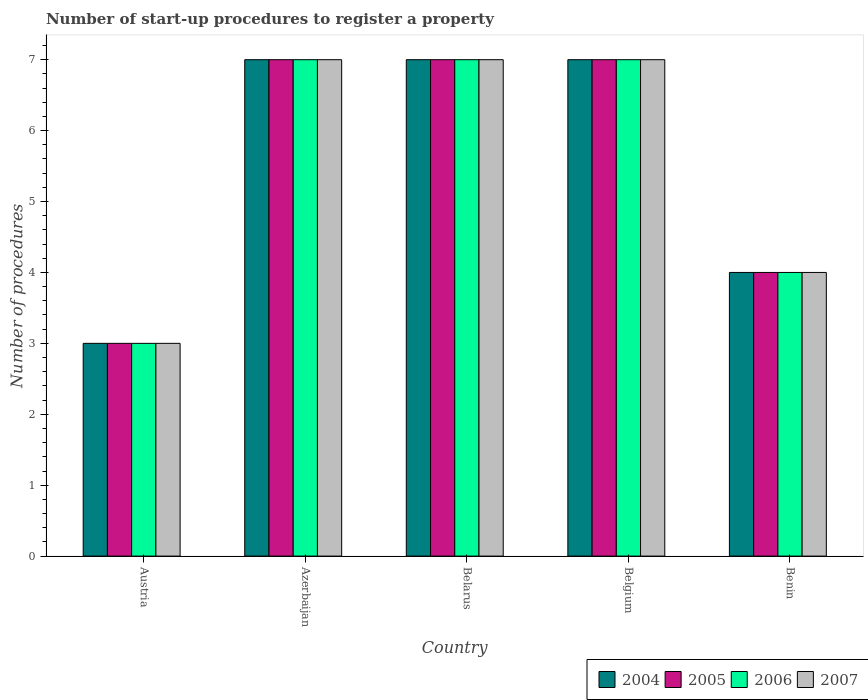How many different coloured bars are there?
Offer a very short reply. 4. How many groups of bars are there?
Offer a very short reply. 5. Are the number of bars per tick equal to the number of legend labels?
Offer a very short reply. Yes. Are the number of bars on each tick of the X-axis equal?
Ensure brevity in your answer.  Yes. How many bars are there on the 1st tick from the left?
Your answer should be compact. 4. How many bars are there on the 2nd tick from the right?
Make the answer very short. 4. What is the label of the 5th group of bars from the left?
Give a very brief answer. Benin. In how many cases, is the number of bars for a given country not equal to the number of legend labels?
Provide a succinct answer. 0. What is the number of procedures required to register a property in 2006 in Benin?
Your answer should be very brief. 4. In which country was the number of procedures required to register a property in 2006 maximum?
Your answer should be very brief. Azerbaijan. What is the difference between the number of procedures required to register a property in 2004 in Austria and the number of procedures required to register a property in 2005 in Belarus?
Give a very brief answer. -4. What is the difference between the number of procedures required to register a property of/in 2006 and number of procedures required to register a property of/in 2007 in Benin?
Offer a very short reply. 0. What is the difference between the highest and the lowest number of procedures required to register a property in 2006?
Keep it short and to the point. 4. Is it the case that in every country, the sum of the number of procedures required to register a property in 2005 and number of procedures required to register a property in 2004 is greater than the sum of number of procedures required to register a property in 2007 and number of procedures required to register a property in 2006?
Your answer should be very brief. No. Is it the case that in every country, the sum of the number of procedures required to register a property in 2005 and number of procedures required to register a property in 2004 is greater than the number of procedures required to register a property in 2007?
Give a very brief answer. Yes. How many countries are there in the graph?
Your response must be concise. 5. Are the values on the major ticks of Y-axis written in scientific E-notation?
Make the answer very short. No. Does the graph contain any zero values?
Offer a terse response. No. Does the graph contain grids?
Offer a very short reply. No. Where does the legend appear in the graph?
Provide a short and direct response. Bottom right. What is the title of the graph?
Make the answer very short. Number of start-up procedures to register a property. Does "1978" appear as one of the legend labels in the graph?
Your answer should be very brief. No. What is the label or title of the X-axis?
Your response must be concise. Country. What is the label or title of the Y-axis?
Your answer should be very brief. Number of procedures. What is the Number of procedures in 2006 in Austria?
Offer a very short reply. 3. What is the Number of procedures in 2007 in Austria?
Your answer should be compact. 3. What is the Number of procedures of 2006 in Azerbaijan?
Your answer should be very brief. 7. What is the Number of procedures of 2007 in Azerbaijan?
Ensure brevity in your answer.  7. What is the Number of procedures in 2004 in Belgium?
Provide a short and direct response. 7. What is the Number of procedures in 2007 in Belgium?
Your answer should be compact. 7. What is the Number of procedures in 2004 in Benin?
Offer a terse response. 4. What is the Number of procedures of 2005 in Benin?
Offer a terse response. 4. What is the Number of procedures of 2006 in Benin?
Offer a terse response. 4. Across all countries, what is the maximum Number of procedures in 2004?
Your answer should be very brief. 7. Across all countries, what is the maximum Number of procedures of 2005?
Ensure brevity in your answer.  7. Across all countries, what is the maximum Number of procedures of 2006?
Keep it short and to the point. 7. Across all countries, what is the minimum Number of procedures of 2006?
Your answer should be very brief. 3. What is the total Number of procedures of 2006 in the graph?
Offer a terse response. 28. What is the difference between the Number of procedures of 2005 in Austria and that in Azerbaijan?
Offer a very short reply. -4. What is the difference between the Number of procedures of 2004 in Austria and that in Belarus?
Offer a terse response. -4. What is the difference between the Number of procedures in 2005 in Austria and that in Belarus?
Provide a short and direct response. -4. What is the difference between the Number of procedures in 2006 in Austria and that in Belarus?
Your answer should be very brief. -4. What is the difference between the Number of procedures in 2007 in Austria and that in Belarus?
Keep it short and to the point. -4. What is the difference between the Number of procedures in 2006 in Austria and that in Belgium?
Your answer should be compact. -4. What is the difference between the Number of procedures in 2007 in Austria and that in Belgium?
Make the answer very short. -4. What is the difference between the Number of procedures in 2004 in Austria and that in Benin?
Offer a terse response. -1. What is the difference between the Number of procedures of 2005 in Austria and that in Benin?
Make the answer very short. -1. What is the difference between the Number of procedures of 2006 in Austria and that in Benin?
Your answer should be very brief. -1. What is the difference between the Number of procedures in 2004 in Azerbaijan and that in Belarus?
Make the answer very short. 0. What is the difference between the Number of procedures in 2005 in Azerbaijan and that in Belarus?
Provide a short and direct response. 0. What is the difference between the Number of procedures of 2005 in Azerbaijan and that in Belgium?
Offer a terse response. 0. What is the difference between the Number of procedures of 2006 in Azerbaijan and that in Belgium?
Ensure brevity in your answer.  0. What is the difference between the Number of procedures of 2004 in Azerbaijan and that in Benin?
Keep it short and to the point. 3. What is the difference between the Number of procedures of 2005 in Azerbaijan and that in Benin?
Your answer should be compact. 3. What is the difference between the Number of procedures in 2007 in Azerbaijan and that in Benin?
Keep it short and to the point. 3. What is the difference between the Number of procedures in 2005 in Belarus and that in Belgium?
Offer a very short reply. 0. What is the difference between the Number of procedures of 2006 in Belarus and that in Belgium?
Your response must be concise. 0. What is the difference between the Number of procedures in 2007 in Belarus and that in Belgium?
Ensure brevity in your answer.  0. What is the difference between the Number of procedures in 2005 in Belarus and that in Benin?
Keep it short and to the point. 3. What is the difference between the Number of procedures of 2006 in Belarus and that in Benin?
Provide a short and direct response. 3. What is the difference between the Number of procedures in 2004 in Belgium and that in Benin?
Provide a short and direct response. 3. What is the difference between the Number of procedures in 2007 in Belgium and that in Benin?
Your response must be concise. 3. What is the difference between the Number of procedures in 2004 in Austria and the Number of procedures in 2005 in Azerbaijan?
Offer a very short reply. -4. What is the difference between the Number of procedures of 2004 in Austria and the Number of procedures of 2006 in Azerbaijan?
Make the answer very short. -4. What is the difference between the Number of procedures of 2005 in Austria and the Number of procedures of 2007 in Azerbaijan?
Provide a short and direct response. -4. What is the difference between the Number of procedures of 2006 in Austria and the Number of procedures of 2007 in Azerbaijan?
Offer a terse response. -4. What is the difference between the Number of procedures in 2004 in Austria and the Number of procedures in 2005 in Belarus?
Your answer should be very brief. -4. What is the difference between the Number of procedures of 2004 in Austria and the Number of procedures of 2006 in Belarus?
Your response must be concise. -4. What is the difference between the Number of procedures of 2004 in Austria and the Number of procedures of 2007 in Belarus?
Give a very brief answer. -4. What is the difference between the Number of procedures of 2005 in Austria and the Number of procedures of 2006 in Belarus?
Make the answer very short. -4. What is the difference between the Number of procedures of 2005 in Austria and the Number of procedures of 2007 in Belarus?
Your response must be concise. -4. What is the difference between the Number of procedures of 2006 in Austria and the Number of procedures of 2007 in Belarus?
Offer a terse response. -4. What is the difference between the Number of procedures in 2004 in Austria and the Number of procedures in 2005 in Belgium?
Keep it short and to the point. -4. What is the difference between the Number of procedures of 2004 in Austria and the Number of procedures of 2007 in Belgium?
Provide a succinct answer. -4. What is the difference between the Number of procedures of 2006 in Austria and the Number of procedures of 2007 in Belgium?
Make the answer very short. -4. What is the difference between the Number of procedures in 2004 in Austria and the Number of procedures in 2005 in Benin?
Keep it short and to the point. -1. What is the difference between the Number of procedures in 2004 in Austria and the Number of procedures in 2006 in Benin?
Make the answer very short. -1. What is the difference between the Number of procedures of 2005 in Austria and the Number of procedures of 2006 in Benin?
Your response must be concise. -1. What is the difference between the Number of procedures of 2006 in Austria and the Number of procedures of 2007 in Benin?
Make the answer very short. -1. What is the difference between the Number of procedures in 2004 in Azerbaijan and the Number of procedures in 2005 in Belarus?
Your response must be concise. 0. What is the difference between the Number of procedures in 2004 in Azerbaijan and the Number of procedures in 2007 in Belarus?
Make the answer very short. 0. What is the difference between the Number of procedures of 2005 in Azerbaijan and the Number of procedures of 2007 in Belarus?
Keep it short and to the point. 0. What is the difference between the Number of procedures of 2006 in Azerbaijan and the Number of procedures of 2007 in Belarus?
Make the answer very short. 0. What is the difference between the Number of procedures in 2004 in Azerbaijan and the Number of procedures in 2005 in Belgium?
Offer a very short reply. 0. What is the difference between the Number of procedures of 2005 in Azerbaijan and the Number of procedures of 2006 in Belgium?
Your answer should be very brief. 0. What is the difference between the Number of procedures of 2004 in Azerbaijan and the Number of procedures of 2006 in Benin?
Offer a terse response. 3. What is the difference between the Number of procedures of 2004 in Azerbaijan and the Number of procedures of 2007 in Benin?
Provide a succinct answer. 3. What is the difference between the Number of procedures of 2005 in Azerbaijan and the Number of procedures of 2006 in Benin?
Give a very brief answer. 3. What is the difference between the Number of procedures of 2006 in Azerbaijan and the Number of procedures of 2007 in Benin?
Give a very brief answer. 3. What is the difference between the Number of procedures of 2004 in Belarus and the Number of procedures of 2005 in Belgium?
Your answer should be very brief. 0. What is the difference between the Number of procedures of 2005 in Belarus and the Number of procedures of 2006 in Belgium?
Ensure brevity in your answer.  0. What is the difference between the Number of procedures of 2006 in Belarus and the Number of procedures of 2007 in Belgium?
Offer a very short reply. 0. What is the difference between the Number of procedures in 2004 in Belarus and the Number of procedures in 2007 in Benin?
Your answer should be compact. 3. What is the difference between the Number of procedures of 2005 in Belarus and the Number of procedures of 2006 in Benin?
Your response must be concise. 3. What is the difference between the Number of procedures of 2006 in Belarus and the Number of procedures of 2007 in Benin?
Offer a very short reply. 3. What is the difference between the Number of procedures of 2004 in Belgium and the Number of procedures of 2005 in Benin?
Give a very brief answer. 3. What is the difference between the Number of procedures in 2005 in Belgium and the Number of procedures in 2006 in Benin?
Ensure brevity in your answer.  3. What is the difference between the Number of procedures in 2005 in Belgium and the Number of procedures in 2007 in Benin?
Your response must be concise. 3. What is the difference between the Number of procedures in 2006 in Belgium and the Number of procedures in 2007 in Benin?
Ensure brevity in your answer.  3. What is the average Number of procedures of 2004 per country?
Your answer should be very brief. 5.6. What is the difference between the Number of procedures in 2004 and Number of procedures in 2005 in Austria?
Keep it short and to the point. 0. What is the difference between the Number of procedures in 2004 and Number of procedures in 2006 in Austria?
Provide a short and direct response. 0. What is the difference between the Number of procedures of 2004 and Number of procedures of 2007 in Austria?
Offer a very short reply. 0. What is the difference between the Number of procedures in 2004 and Number of procedures in 2007 in Azerbaijan?
Provide a succinct answer. 0. What is the difference between the Number of procedures in 2005 and Number of procedures in 2007 in Azerbaijan?
Your response must be concise. 0. What is the difference between the Number of procedures of 2006 and Number of procedures of 2007 in Azerbaijan?
Ensure brevity in your answer.  0. What is the difference between the Number of procedures of 2005 and Number of procedures of 2006 in Belarus?
Offer a terse response. 0. What is the difference between the Number of procedures of 2006 and Number of procedures of 2007 in Belarus?
Provide a short and direct response. 0. What is the difference between the Number of procedures in 2004 and Number of procedures in 2006 in Belgium?
Offer a terse response. 0. What is the difference between the Number of procedures in 2004 and Number of procedures in 2007 in Belgium?
Offer a very short reply. 0. What is the difference between the Number of procedures in 2005 and Number of procedures in 2006 in Belgium?
Offer a terse response. 0. What is the difference between the Number of procedures of 2006 and Number of procedures of 2007 in Belgium?
Keep it short and to the point. 0. What is the difference between the Number of procedures of 2004 and Number of procedures of 2005 in Benin?
Keep it short and to the point. 0. What is the difference between the Number of procedures in 2004 and Number of procedures in 2006 in Benin?
Make the answer very short. 0. What is the ratio of the Number of procedures in 2004 in Austria to that in Azerbaijan?
Keep it short and to the point. 0.43. What is the ratio of the Number of procedures of 2005 in Austria to that in Azerbaijan?
Offer a terse response. 0.43. What is the ratio of the Number of procedures of 2006 in Austria to that in Azerbaijan?
Offer a terse response. 0.43. What is the ratio of the Number of procedures of 2007 in Austria to that in Azerbaijan?
Your answer should be compact. 0.43. What is the ratio of the Number of procedures in 2004 in Austria to that in Belarus?
Provide a short and direct response. 0.43. What is the ratio of the Number of procedures of 2005 in Austria to that in Belarus?
Your answer should be very brief. 0.43. What is the ratio of the Number of procedures of 2006 in Austria to that in Belarus?
Make the answer very short. 0.43. What is the ratio of the Number of procedures of 2007 in Austria to that in Belarus?
Offer a terse response. 0.43. What is the ratio of the Number of procedures of 2004 in Austria to that in Belgium?
Your response must be concise. 0.43. What is the ratio of the Number of procedures of 2005 in Austria to that in Belgium?
Your response must be concise. 0.43. What is the ratio of the Number of procedures of 2006 in Austria to that in Belgium?
Your answer should be very brief. 0.43. What is the ratio of the Number of procedures of 2007 in Austria to that in Belgium?
Offer a terse response. 0.43. What is the ratio of the Number of procedures of 2005 in Austria to that in Benin?
Your answer should be very brief. 0.75. What is the ratio of the Number of procedures of 2007 in Austria to that in Benin?
Provide a short and direct response. 0.75. What is the ratio of the Number of procedures of 2005 in Azerbaijan to that in Belarus?
Keep it short and to the point. 1. What is the ratio of the Number of procedures of 2006 in Azerbaijan to that in Belarus?
Your answer should be very brief. 1. What is the ratio of the Number of procedures in 2007 in Azerbaijan to that in Belarus?
Keep it short and to the point. 1. What is the ratio of the Number of procedures in 2004 in Azerbaijan to that in Benin?
Offer a very short reply. 1.75. What is the ratio of the Number of procedures of 2006 in Azerbaijan to that in Benin?
Provide a short and direct response. 1.75. What is the ratio of the Number of procedures in 2007 in Azerbaijan to that in Benin?
Your answer should be compact. 1.75. What is the ratio of the Number of procedures of 2004 in Belarus to that in Belgium?
Keep it short and to the point. 1. What is the ratio of the Number of procedures in 2006 in Belarus to that in Belgium?
Offer a terse response. 1. What is the ratio of the Number of procedures of 2007 in Belarus to that in Belgium?
Ensure brevity in your answer.  1. What is the ratio of the Number of procedures in 2004 in Belarus to that in Benin?
Your answer should be compact. 1.75. What is the ratio of the Number of procedures of 2006 in Belarus to that in Benin?
Make the answer very short. 1.75. What is the ratio of the Number of procedures of 2007 in Belarus to that in Benin?
Your answer should be very brief. 1.75. What is the ratio of the Number of procedures in 2005 in Belgium to that in Benin?
Ensure brevity in your answer.  1.75. What is the difference between the highest and the second highest Number of procedures of 2004?
Provide a succinct answer. 0. What is the difference between the highest and the second highest Number of procedures of 2005?
Keep it short and to the point. 0. What is the difference between the highest and the lowest Number of procedures of 2004?
Keep it short and to the point. 4. What is the difference between the highest and the lowest Number of procedures in 2006?
Your answer should be compact. 4. What is the difference between the highest and the lowest Number of procedures of 2007?
Your answer should be compact. 4. 